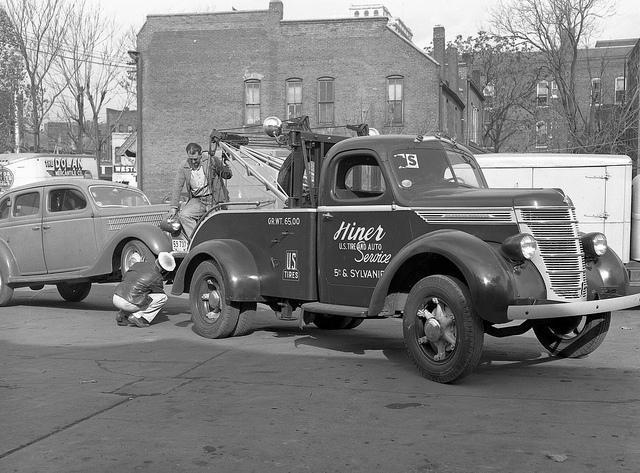How many men are there?
Give a very brief answer. 2. How many people are visible?
Give a very brief answer. 2. 